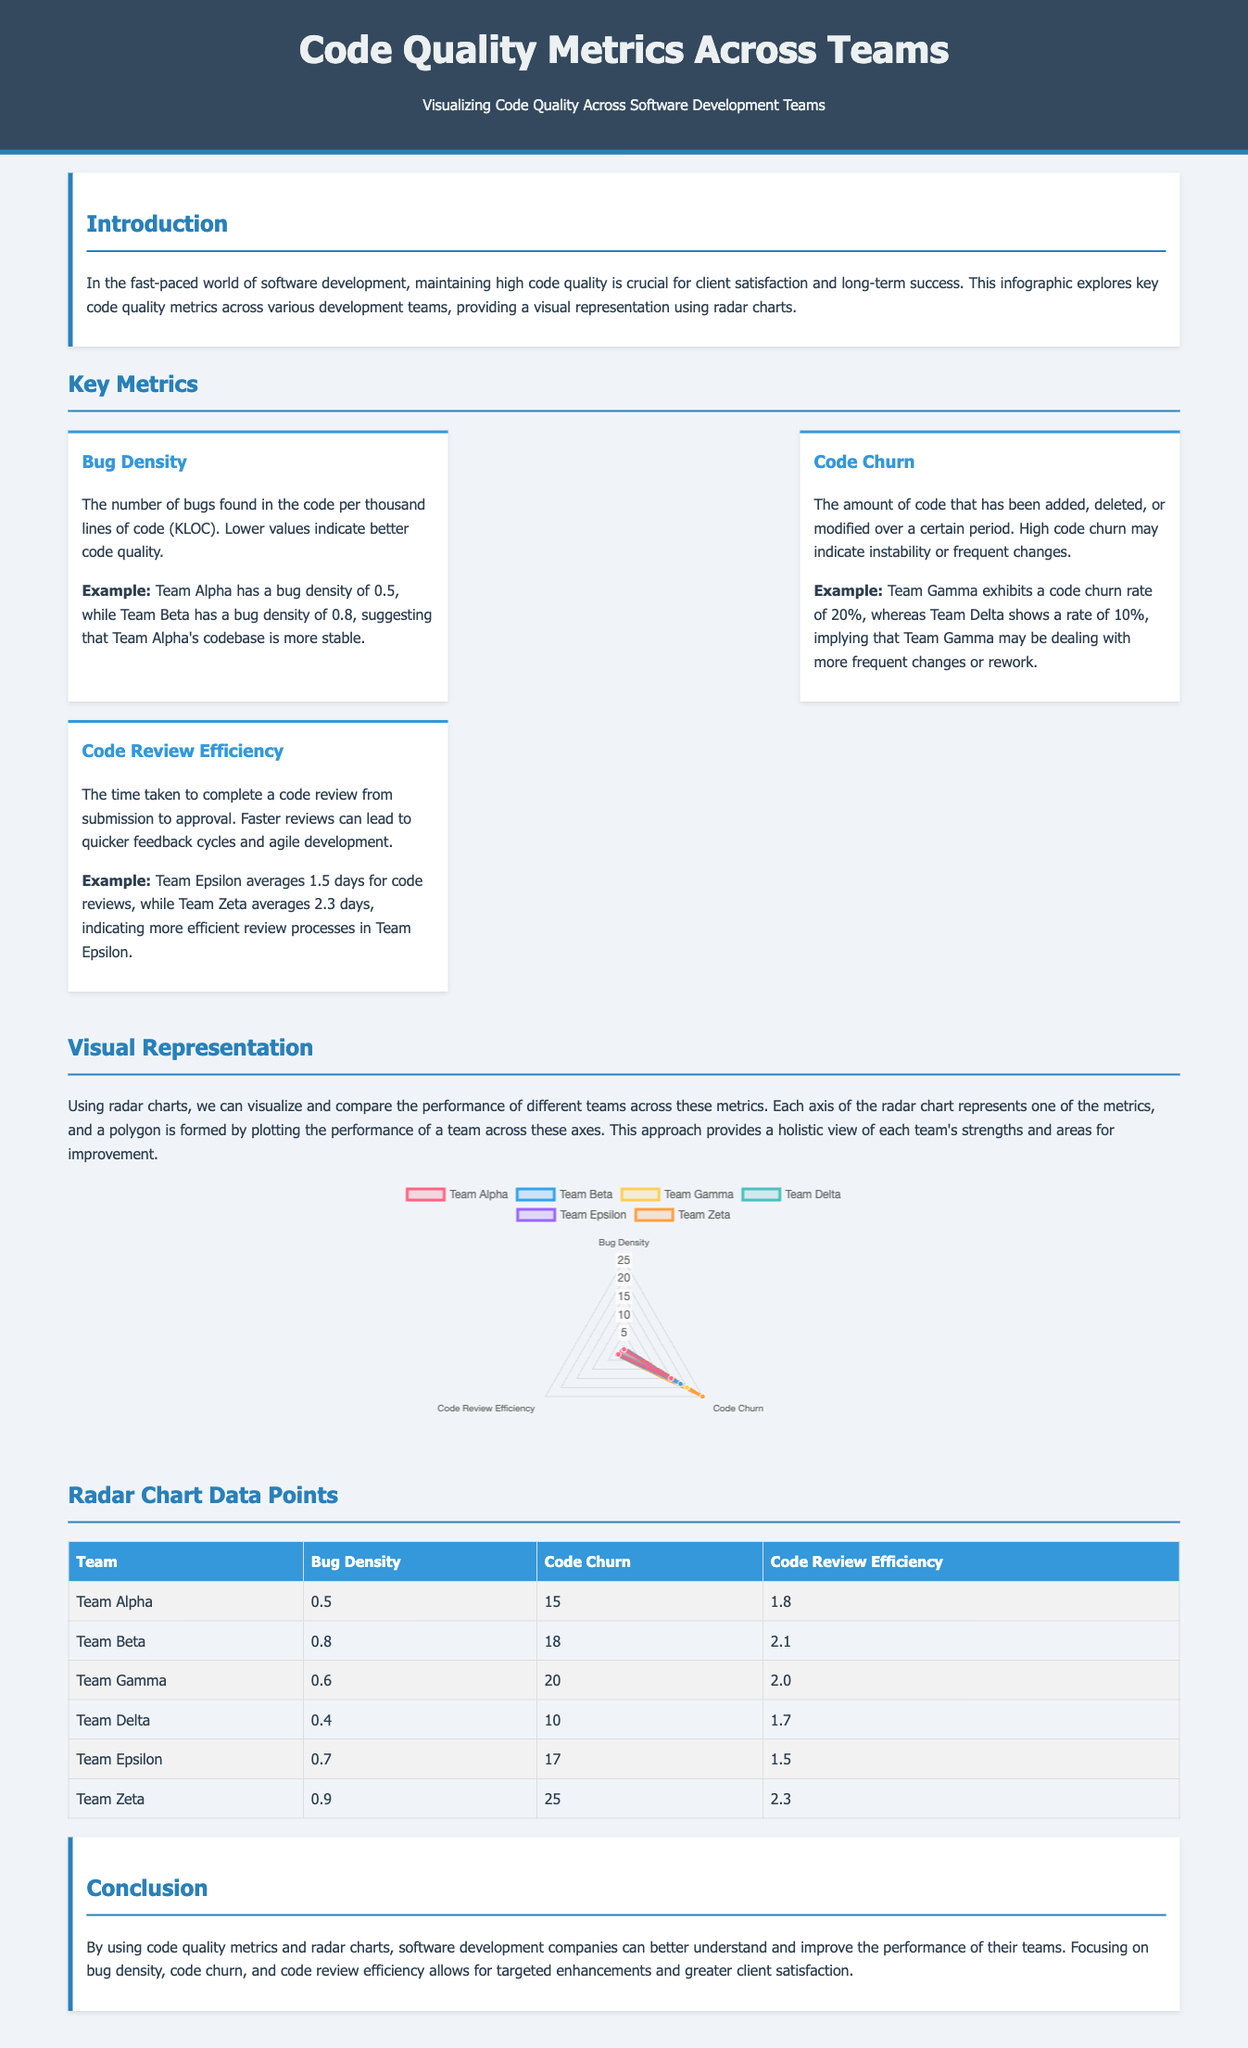What is the primary focus of the infographic? The infographic primarily focuses on visualizing key code quality metrics across various development teams, highlighting their performance.
Answer: Code quality metrics Which team has the lowest bug density? The lowest bug density is presented in the table under the "Bug Density" column, displaying Team Delta's value.
Answer: Team Delta What is the code churn rate for Team Zeta? The code churn rate for Team Zeta is specified in the data table as 25 percent.
Answer: 25 Which team is the most efficient in code review speed? The efficiency of code review speed is indicated in the "Code Review Efficiency" column, where Team Epsilon has the shortest duration.
Answer: Team Epsilon What value signifies Team Alpha's code churn percentage? Team Alpha's code churn value, which can be found in the metrics table, represents the percentage of code changes.
Answer: 15 Which metric indicates the number of bugs found per KLOC? The metric which indicates bugs per KLOC is referred to as "Bug Density" in the key metrics section.
Answer: Bug Density What is the average code review time for Team Beta? The average code review time for Team Beta can be referenced in the table under the "Code Review Efficiency" column.
Answer: 2.1 Which team has the highest code churn rate? The highest code churn rate is listed in the table, indicating which team has the most significant percentage of code change activity.
Answer: Team Zeta 